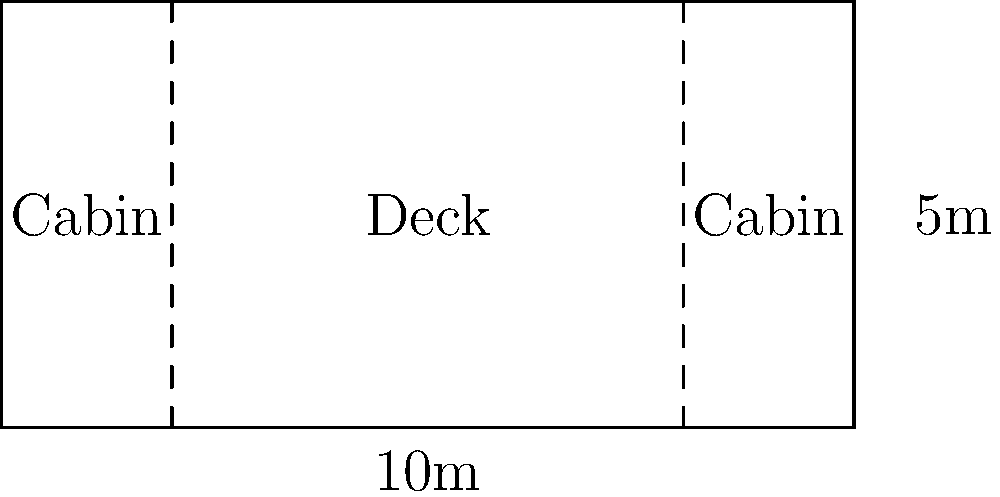As the newly appointed safety officer on a luxury yacht, you're tasked with determining the maximum passenger capacity. The yacht measures 10m in length and 5m in width, as shown in the floor plan. According to safety regulations, each passenger must have a minimum of 2 square meters of deck space. Additionally, 20% of the total deck area must be reserved for safety equipment and crew movement. Calculate the maximum number of passengers allowed on this yacht. To solve this problem, we'll follow these steps:

1. Calculate the total deck area:
   Area = Length × Width
   Area = 10m × 5m = 50 m²

2. Calculate the area reserved for safety equipment and crew movement (20% of total):
   Reserved area = 20% × 50 m² = 0.2 × 50 m² = 10 m²

3. Calculate the available area for passengers:
   Available area = Total area - Reserved area
   Available area = 50 m² - 10 m² = 40 m²

4. Calculate the number of passengers based on the 2 m² per person requirement:
   Maximum passengers = Available area ÷ Area per passenger
   Maximum passengers = 40 m² ÷ 2 m² = 20

5. Since we can't have a fraction of a person, we round down to the nearest whole number.

Therefore, the maximum number of passengers allowed on this yacht is 20.
Answer: 20 passengers 